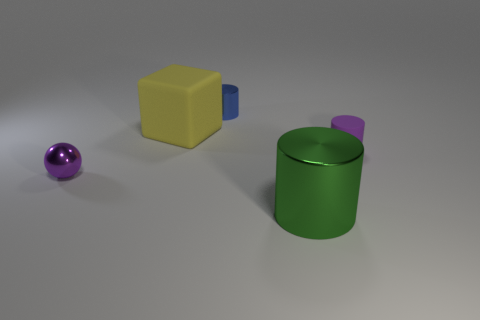How big is the blue cylinder?
Keep it short and to the point. Small. What number of purple rubber things have the same size as the green shiny thing?
Give a very brief answer. 0. What is the material of the tiny purple object that is the same shape as the big green object?
Make the answer very short. Rubber. The thing that is behind the tiny purple matte object and left of the small blue object has what shape?
Offer a very short reply. Cube. There is a small object on the left side of the tiny metallic cylinder; what shape is it?
Give a very brief answer. Sphere. What number of metallic objects are both in front of the small blue metal cylinder and behind the large matte thing?
Keep it short and to the point. 0. Is the size of the purple ball the same as the shiny cylinder behind the purple matte cylinder?
Give a very brief answer. Yes. How big is the shiny cylinder behind the object that is in front of the object that is left of the yellow rubber cube?
Keep it short and to the point. Small. What is the size of the purple object left of the blue cylinder?
Offer a terse response. Small. What shape is the other tiny object that is the same material as the blue thing?
Provide a short and direct response. Sphere. 